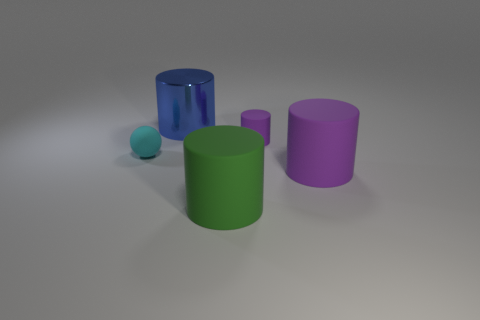How many purple cylinders must be subtracted to get 1 purple cylinders? 1 Subtract 1 cylinders. How many cylinders are left? 3 Add 1 rubber things. How many objects exist? 6 Subtract all balls. How many objects are left? 4 Subtract 0 brown cylinders. How many objects are left? 5 Subtract all cyan metal balls. Subtract all big purple cylinders. How many objects are left? 4 Add 5 large matte cylinders. How many large matte cylinders are left? 7 Add 1 cyan balls. How many cyan balls exist? 2 